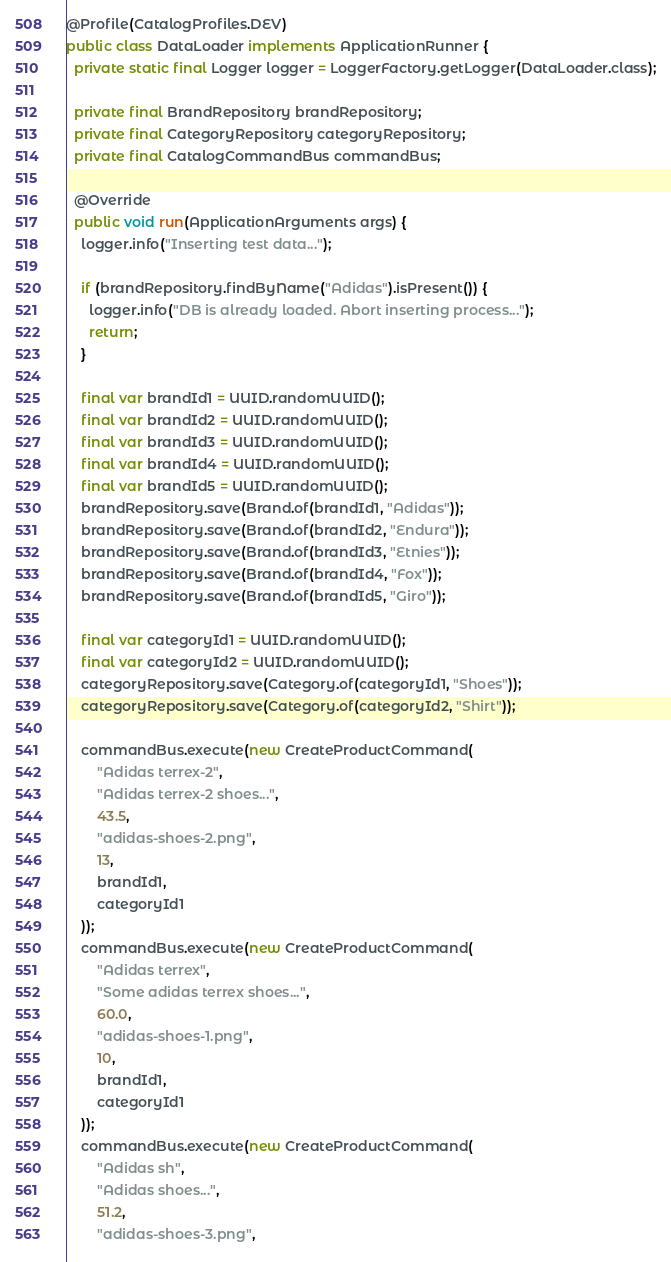Convert code to text. <code><loc_0><loc_0><loc_500><loc_500><_Java_>@Profile(CatalogProfiles.DEV)
public class DataLoader implements ApplicationRunner {
  private static final Logger logger = LoggerFactory.getLogger(DataLoader.class);

  private final BrandRepository brandRepository;
  private final CategoryRepository categoryRepository;
  private final CatalogCommandBus commandBus;

  @Override
  public void run(ApplicationArguments args) {
    logger.info("Inserting test data...");

    if (brandRepository.findByName("Adidas").isPresent()) {
      logger.info("DB is already loaded. Abort inserting process...");
      return;
    }

    final var brandId1 = UUID.randomUUID();
    final var brandId2 = UUID.randomUUID();
    final var brandId3 = UUID.randomUUID();
    final var brandId4 = UUID.randomUUID();
    final var brandId5 = UUID.randomUUID();
    brandRepository.save(Brand.of(brandId1, "Adidas"));
    brandRepository.save(Brand.of(brandId2, "Endura"));
    brandRepository.save(Brand.of(brandId3, "Etnies"));
    brandRepository.save(Brand.of(brandId4, "Fox"));
    brandRepository.save(Brand.of(brandId5, "Giro"));

    final var categoryId1 = UUID.randomUUID();
    final var categoryId2 = UUID.randomUUID();
    categoryRepository.save(Category.of(categoryId1, "Shoes"));
    categoryRepository.save(Category.of(categoryId2, "Shirt"));

    commandBus.execute(new CreateProductCommand(
        "Adidas terrex-2",
        "Adidas terrex-2 shoes...",
        43.5,
        "adidas-shoes-2.png",
        13,
        brandId1,
        categoryId1
    ));
    commandBus.execute(new CreateProductCommand(
        "Adidas terrex",
        "Some adidas terrex shoes...",
        60.0,
        "adidas-shoes-1.png",
        10,
        brandId1,
        categoryId1
    ));
    commandBus.execute(new CreateProductCommand(
        "Adidas sh",
        "Adidas shoes...",
        51.2,
        "adidas-shoes-3.png",</code> 